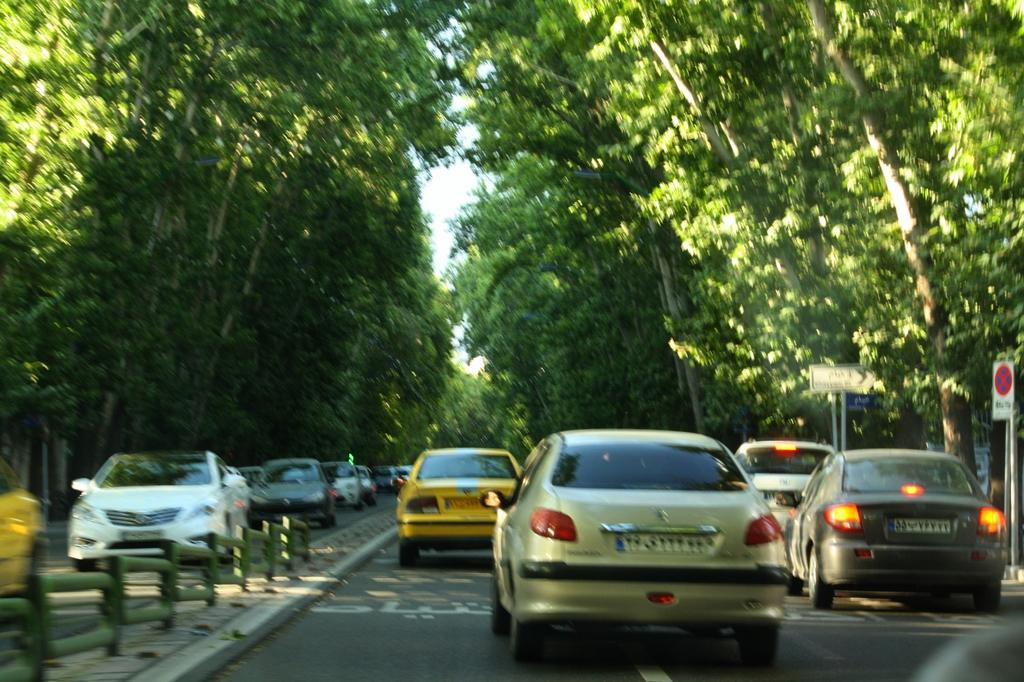What can be seen on the road in the image? There are vehicles on the road in the image. What type of fencing is present in the image? There is rod fencing in the image. What are the sign boards with poles used for in the image? The sign boards with poles are used for providing information or directions in the image. What can be seen in the background of the image? There are trees and the sky visible in the background of the image. What type of stick can be seen in the image? There is no stick present in the image. Is the image taken during winter? The provided facts do not mention the season, so it cannot be determined if the image was taken during winter. 